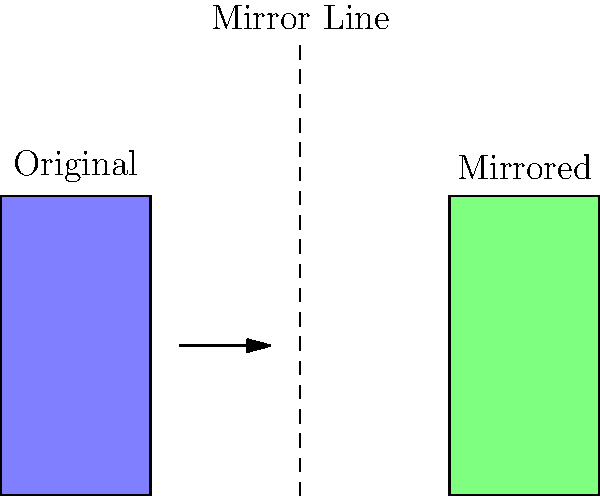In hand therapy, visualizing mirror images of tools is crucial for bilateral treatments. If the blue shape represents a hand therapy tool, which of the following best describes the green shape?
A) Rotation of the original tool
B) Mirror image of the original tool
C) Enlarged version of the original tool
D) Inverted image of the original tool To solve this problem, let's analyze the image step-by-step:

1. We see two shapes: a blue one on the left and a green one on the right.
2. There's a dashed line in the middle, labeled "Mirror Line."
3. The blue shape (labeled "Original") is a rectangular tool with specific dimensions.
4. The green shape (labeled "Mirrored") appears to be identical in size and shape to the blue one.
5. However, the green shape is flipped horizontally compared to the blue one.
6. The arrow between the shapes indicates a transformation from left to right.

Given these observations:
- The shapes are not rotated relative to each other, ruling out option A.
- The green shape is not larger than the blue one, eliminating option C.
- The green shape is not inverted (turned upside down), so option D is incorrect.

The green shape is a perfect horizontal flip of the blue shape, with the dashed line acting as the axis of reflection. This is the definition of a mirror image.

Therefore, the correct answer is B) Mirror image of the original tool.

This concept is important in occupational therapy, especially for hand therapy, as it relates to bilateral treatments where therapists need to visualize and apply techniques symmetrically on both sides of the body.
Answer: B) Mirror image of the original tool 